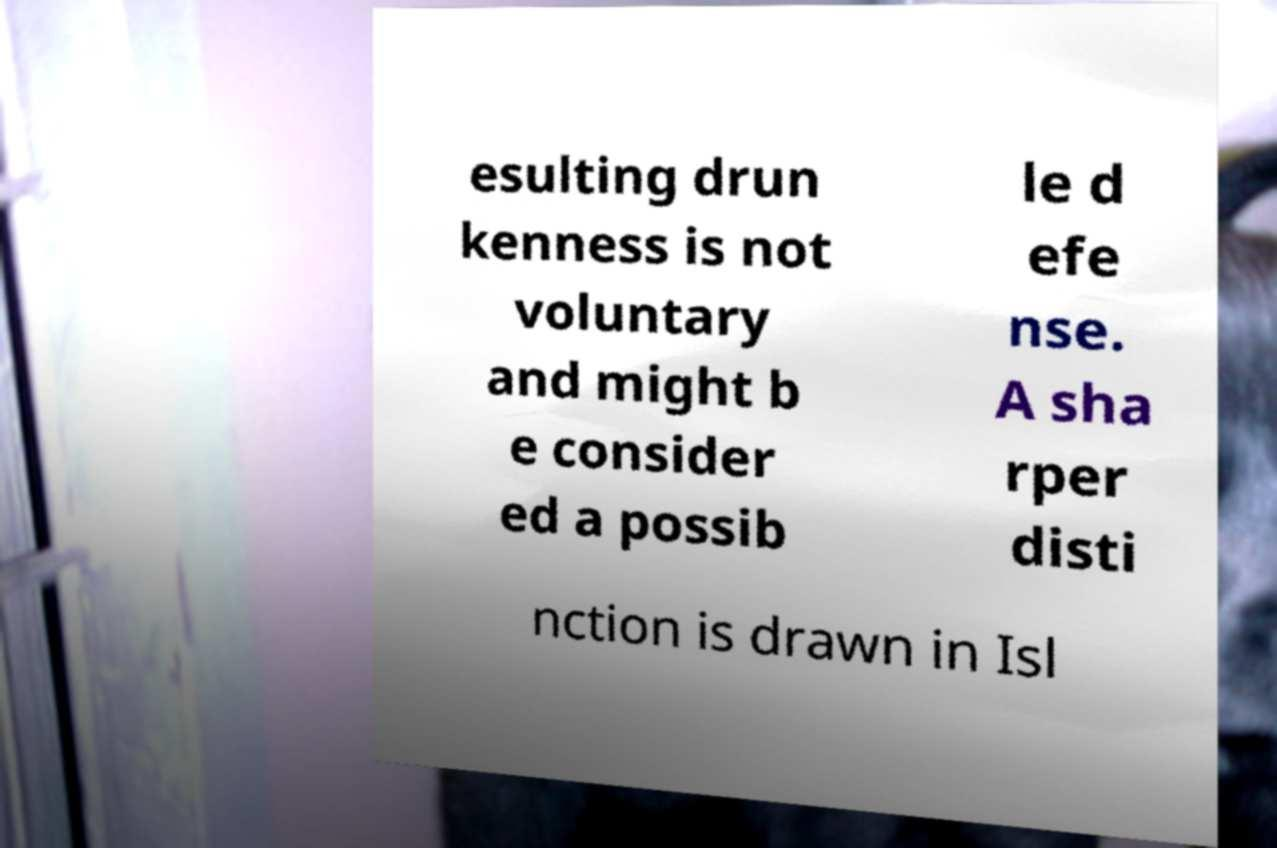For documentation purposes, I need the text within this image transcribed. Could you provide that? esulting drun kenness is not voluntary and might b e consider ed a possib le d efe nse. A sha rper disti nction is drawn in Isl 